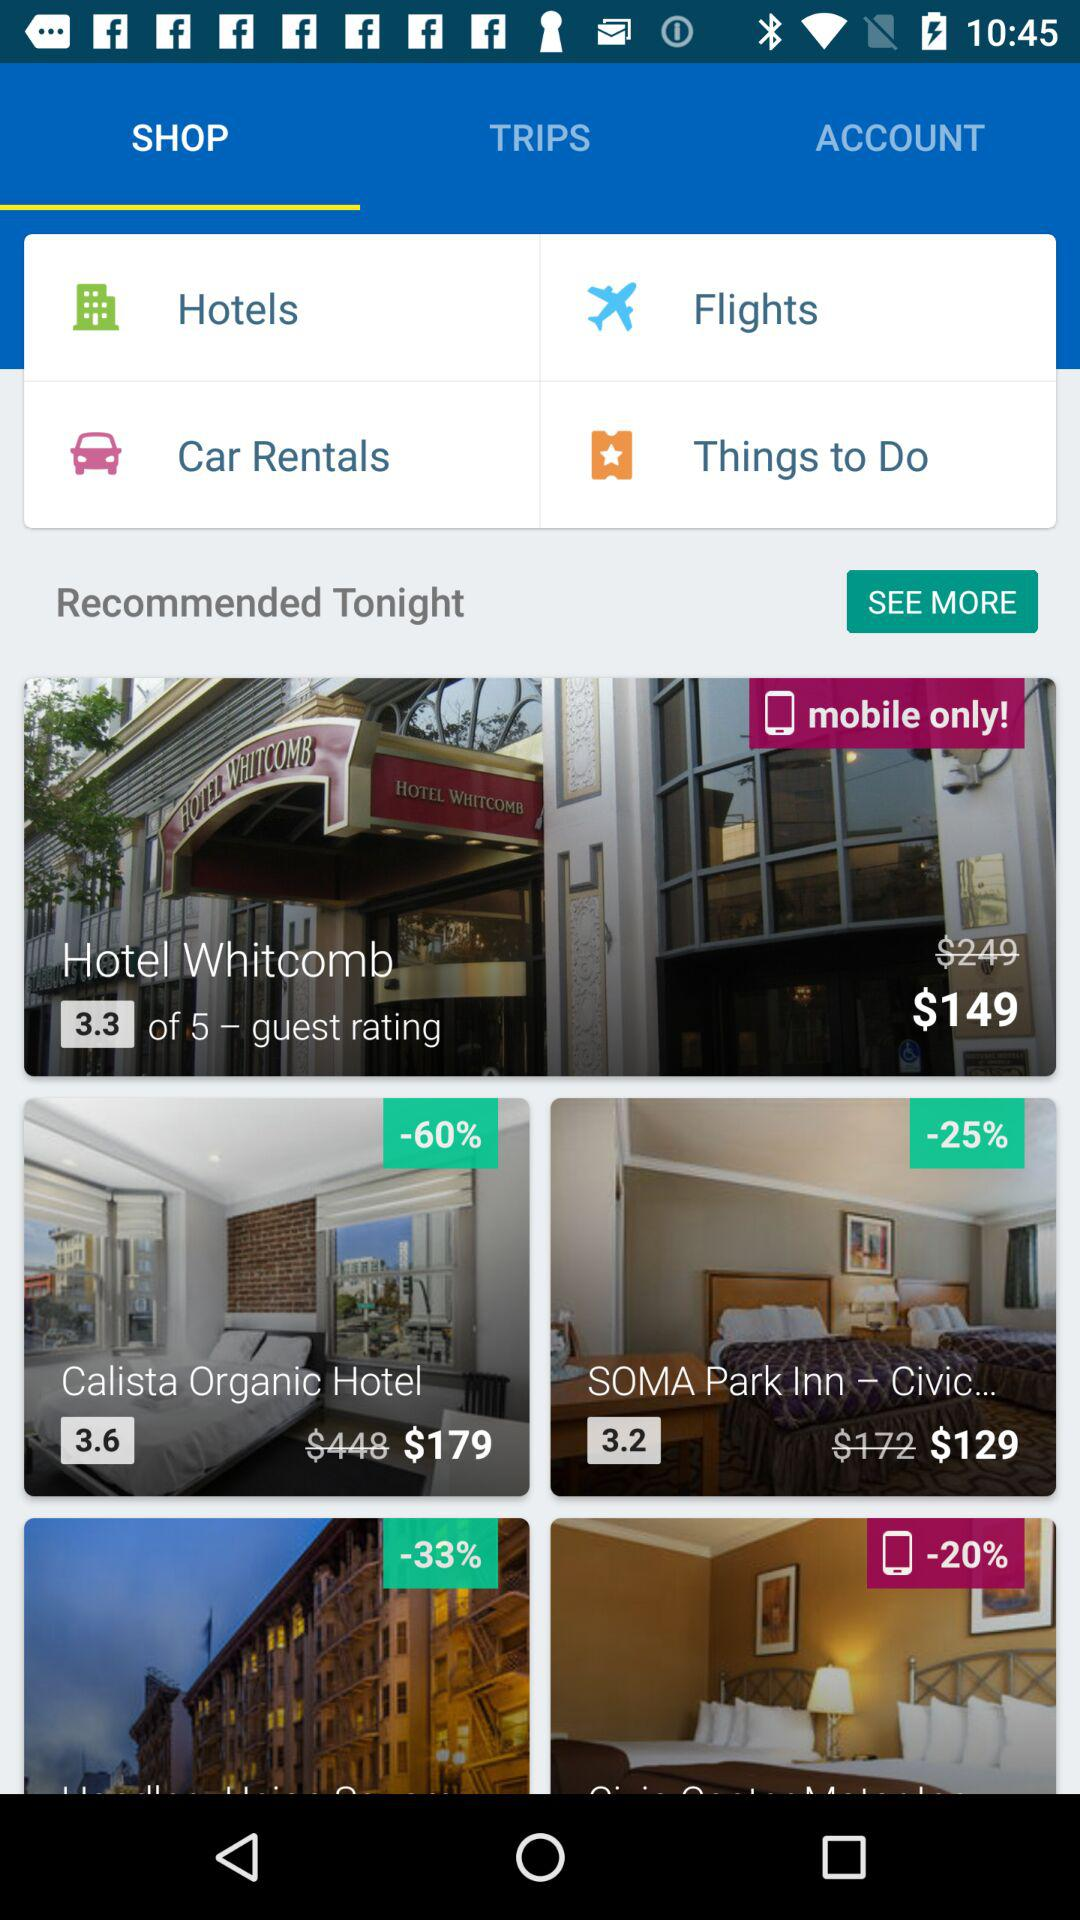What is the selected option? The selected option is "SHOP". 